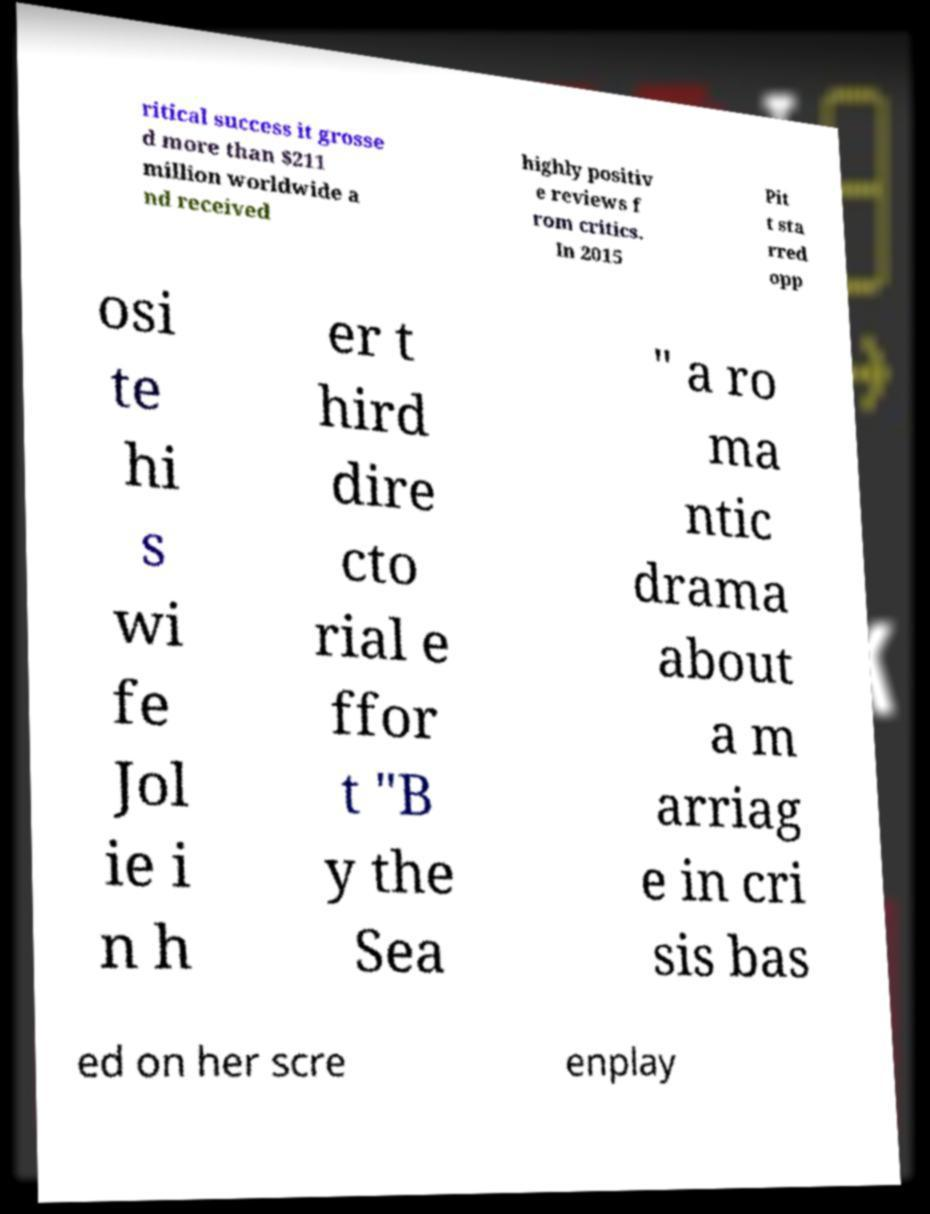For documentation purposes, I need the text within this image transcribed. Could you provide that? ritical success it grosse d more than $211 million worldwide a nd received highly positiv e reviews f rom critics. In 2015 Pit t sta rred opp osi te hi s wi fe Jol ie i n h er t hird dire cto rial e ffor t "B y the Sea " a ro ma ntic drama about a m arriag e in cri sis bas ed on her scre enplay 